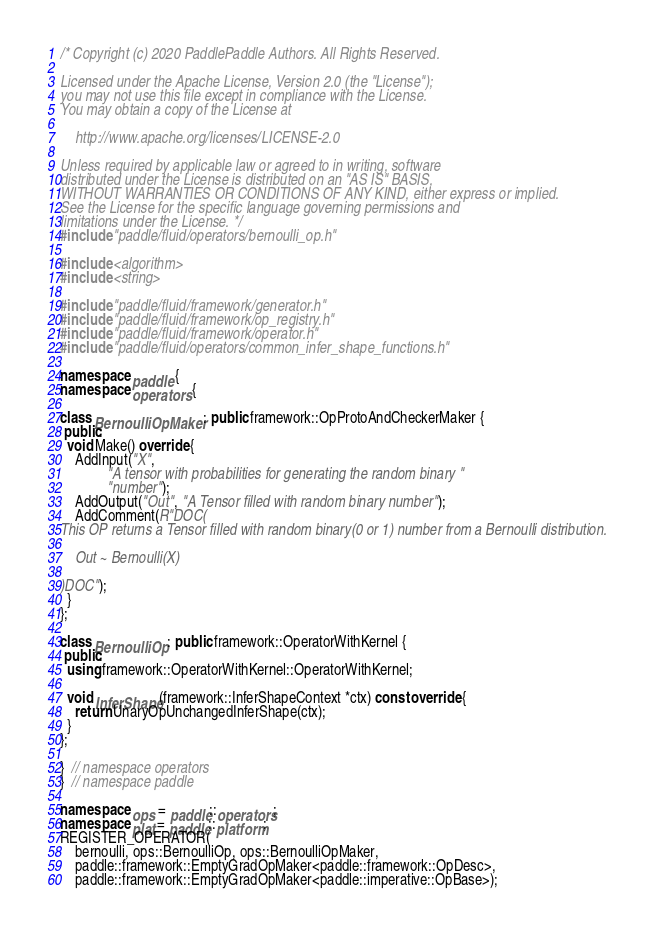<code> <loc_0><loc_0><loc_500><loc_500><_C++_>/* Copyright (c) 2020 PaddlePaddle Authors. All Rights Reserved.

Licensed under the Apache License, Version 2.0 (the "License");
you may not use this file except in compliance with the License.
You may obtain a copy of the License at

    http://www.apache.org/licenses/LICENSE-2.0

Unless required by applicable law or agreed to in writing, software
distributed under the License is distributed on an "AS IS" BASIS,
WITHOUT WARRANTIES OR CONDITIONS OF ANY KIND, either express or implied.
See the License for the specific language governing permissions and
limitations under the License. */
#include "paddle/fluid/operators/bernoulli_op.h"

#include <algorithm>
#include <string>

#include "paddle/fluid/framework/generator.h"
#include "paddle/fluid/framework/op_registry.h"
#include "paddle/fluid/framework/operator.h"
#include "paddle/fluid/operators/common_infer_shape_functions.h"

namespace paddle {
namespace operators {

class BernoulliOpMaker : public framework::OpProtoAndCheckerMaker {
 public:
  void Make() override {
    AddInput("X",
             "A tensor with probabilities for generating the random binary "
             "number");
    AddOutput("Out", "A Tensor filled with random binary number");
    AddComment(R"DOC(
This OP returns a Tensor filled with random binary(0 or 1) number from a Bernoulli distribution.

    Out ~ Bernoulli(X)

)DOC");
  }
};

class BernoulliOp : public framework::OperatorWithKernel {
 public:
  using framework::OperatorWithKernel::OperatorWithKernel;

  void InferShape(framework::InferShapeContext *ctx) const override {
    return UnaryOpUnchangedInferShape(ctx);
  }
};

}  // namespace operators
}  // namespace paddle

namespace ops = paddle::operators;
namespace plat = paddle::platform;
REGISTER_OPERATOR(
    bernoulli, ops::BernoulliOp, ops::BernoulliOpMaker,
    paddle::framework::EmptyGradOpMaker<paddle::framework::OpDesc>,
    paddle::framework::EmptyGradOpMaker<paddle::imperative::OpBase>);
</code> 